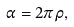Convert formula to latex. <formula><loc_0><loc_0><loc_500><loc_500>\alpha = 2 \pi \rho ,</formula> 